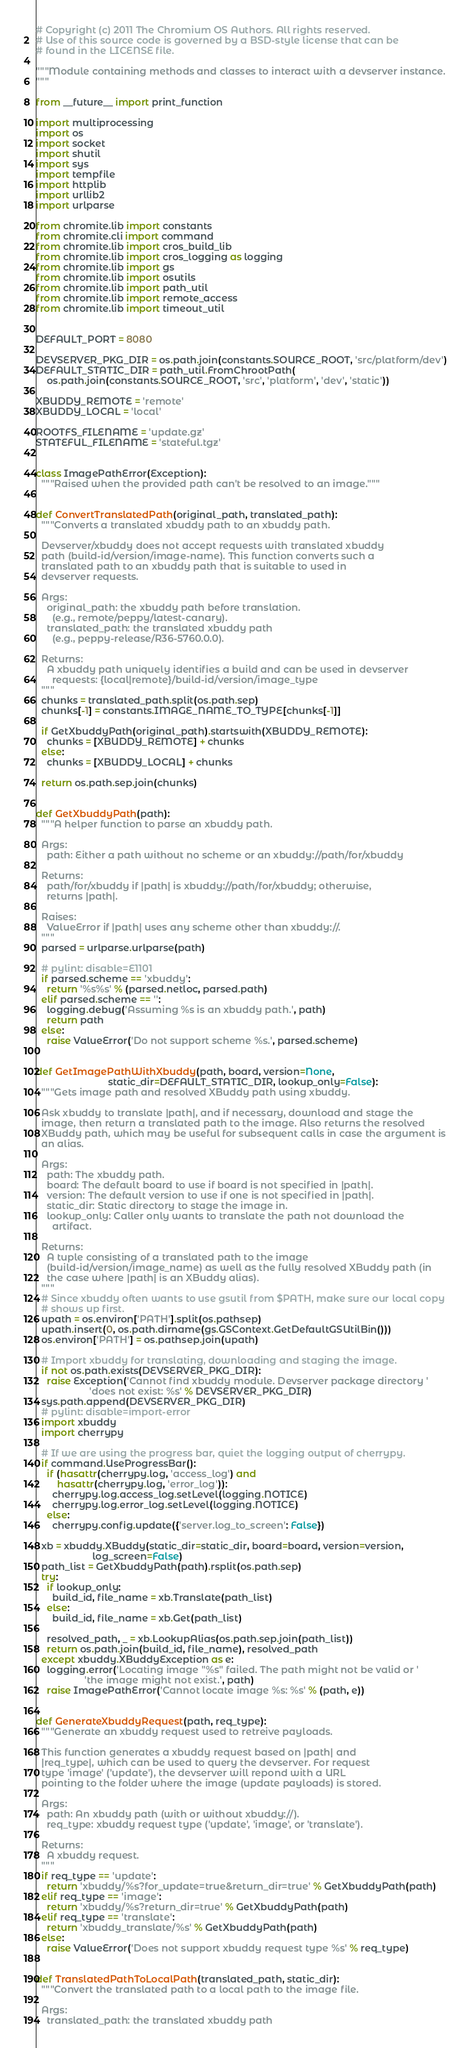<code> <loc_0><loc_0><loc_500><loc_500><_Python_># Copyright (c) 2011 The Chromium OS Authors. All rights reserved.
# Use of this source code is governed by a BSD-style license that can be
# found in the LICENSE file.

"""Module containing methods and classes to interact with a devserver instance.
"""

from __future__ import print_function

import multiprocessing
import os
import socket
import shutil
import sys
import tempfile
import httplib
import urllib2
import urlparse

from chromite.lib import constants
from chromite.cli import command
from chromite.lib import cros_build_lib
from chromite.lib import cros_logging as logging
from chromite.lib import gs
from chromite.lib import osutils
from chromite.lib import path_util
from chromite.lib import remote_access
from chromite.lib import timeout_util


DEFAULT_PORT = 8080

DEVSERVER_PKG_DIR = os.path.join(constants.SOURCE_ROOT, 'src/platform/dev')
DEFAULT_STATIC_DIR = path_util.FromChrootPath(
    os.path.join(constants.SOURCE_ROOT, 'src', 'platform', 'dev', 'static'))

XBUDDY_REMOTE = 'remote'
XBUDDY_LOCAL = 'local'

ROOTFS_FILENAME = 'update.gz'
STATEFUL_FILENAME = 'stateful.tgz'


class ImagePathError(Exception):
  """Raised when the provided path can't be resolved to an image."""


def ConvertTranslatedPath(original_path, translated_path):
  """Converts a translated xbuddy path to an xbuddy path.

  Devserver/xbuddy does not accept requests with translated xbuddy
  path (build-id/version/image-name). This function converts such a
  translated path to an xbuddy path that is suitable to used in
  devserver requests.

  Args:
    original_path: the xbuddy path before translation.
      (e.g., remote/peppy/latest-canary).
    translated_path: the translated xbuddy path
      (e.g., peppy-release/R36-5760.0.0).

  Returns:
    A xbuddy path uniquely identifies a build and can be used in devserver
      requests: {local|remote}/build-id/version/image_type
  """
  chunks = translated_path.split(os.path.sep)
  chunks[-1] = constants.IMAGE_NAME_TO_TYPE[chunks[-1]]

  if GetXbuddyPath(original_path).startswith(XBUDDY_REMOTE):
    chunks = [XBUDDY_REMOTE] + chunks
  else:
    chunks = [XBUDDY_LOCAL] + chunks

  return os.path.sep.join(chunks)


def GetXbuddyPath(path):
  """A helper function to parse an xbuddy path.

  Args:
    path: Either a path without no scheme or an xbuddy://path/for/xbuddy

  Returns:
    path/for/xbuddy if |path| is xbuddy://path/for/xbuddy; otherwise,
    returns |path|.

  Raises:
    ValueError if |path| uses any scheme other than xbuddy://.
  """
  parsed = urlparse.urlparse(path)

  # pylint: disable=E1101
  if parsed.scheme == 'xbuddy':
    return '%s%s' % (parsed.netloc, parsed.path)
  elif parsed.scheme == '':
    logging.debug('Assuming %s is an xbuddy path.', path)
    return path
  else:
    raise ValueError('Do not support scheme %s.', parsed.scheme)


def GetImagePathWithXbuddy(path, board, version=None,
                           static_dir=DEFAULT_STATIC_DIR, lookup_only=False):
  """Gets image path and resolved XBuddy path using xbuddy.

  Ask xbuddy to translate |path|, and if necessary, download and stage the
  image, then return a translated path to the image. Also returns the resolved
  XBuddy path, which may be useful for subsequent calls in case the argument is
  an alias.

  Args:
    path: The xbuddy path.
    board: The default board to use if board is not specified in |path|.
    version: The default version to use if one is not specified in |path|.
    static_dir: Static directory to stage the image in.
    lookup_only: Caller only wants to translate the path not download the
      artifact.

  Returns:
    A tuple consisting of a translated path to the image
    (build-id/version/image_name) as well as the fully resolved XBuddy path (in
    the case where |path| is an XBuddy alias).
  """
  # Since xbuddy often wants to use gsutil from $PATH, make sure our local copy
  # shows up first.
  upath = os.environ['PATH'].split(os.pathsep)
  upath.insert(0, os.path.dirname(gs.GSContext.GetDefaultGSUtilBin()))
  os.environ['PATH'] = os.pathsep.join(upath)

  # Import xbuddy for translating, downloading and staging the image.
  if not os.path.exists(DEVSERVER_PKG_DIR):
    raise Exception('Cannot find xbuddy module. Devserver package directory '
                    'does not exist: %s' % DEVSERVER_PKG_DIR)
  sys.path.append(DEVSERVER_PKG_DIR)
  # pylint: disable=import-error
  import xbuddy
  import cherrypy

  # If we are using the progress bar, quiet the logging output of cherrypy.
  if command.UseProgressBar():
    if (hasattr(cherrypy.log, 'access_log') and
        hasattr(cherrypy.log, 'error_log')):
      cherrypy.log.access_log.setLevel(logging.NOTICE)
      cherrypy.log.error_log.setLevel(logging.NOTICE)
    else:
      cherrypy.config.update({'server.log_to_screen': False})

  xb = xbuddy.XBuddy(static_dir=static_dir, board=board, version=version,
                     log_screen=False)
  path_list = GetXbuddyPath(path).rsplit(os.path.sep)
  try:
    if lookup_only:
      build_id, file_name = xb.Translate(path_list)
    else:
      build_id, file_name = xb.Get(path_list)

    resolved_path, _ = xb.LookupAlias(os.path.sep.join(path_list))
    return os.path.join(build_id, file_name), resolved_path
  except xbuddy.XBuddyException as e:
    logging.error('Locating image "%s" failed. The path might not be valid or '
                  'the image might not exist.', path)
    raise ImagePathError('Cannot locate image %s: %s' % (path, e))


def GenerateXbuddyRequest(path, req_type):
  """Generate an xbuddy request used to retreive payloads.

  This function generates a xbuddy request based on |path| and
  |req_type|, which can be used to query the devserver. For request
  type 'image' ('update'), the devserver will repond with a URL
  pointing to the folder where the image (update payloads) is stored.

  Args:
    path: An xbuddy path (with or without xbuddy://).
    req_type: xbuddy request type ('update', 'image', or 'translate').

  Returns:
    A xbuddy request.
  """
  if req_type == 'update':
    return 'xbuddy/%s?for_update=true&return_dir=true' % GetXbuddyPath(path)
  elif req_type == 'image':
    return 'xbuddy/%s?return_dir=true' % GetXbuddyPath(path)
  elif req_type == 'translate':
    return 'xbuddy_translate/%s' % GetXbuddyPath(path)
  else:
    raise ValueError('Does not support xbuddy request type %s' % req_type)


def TranslatedPathToLocalPath(translated_path, static_dir):
  """Convert the translated path to a local path to the image file.

  Args:
    translated_path: the translated xbuddy path</code> 